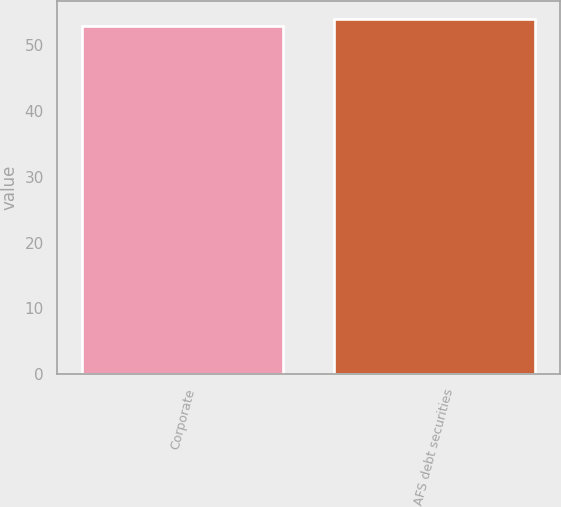<chart> <loc_0><loc_0><loc_500><loc_500><bar_chart><fcel>Corporate<fcel>AFS debt securities<nl><fcel>53<fcel>54<nl></chart> 